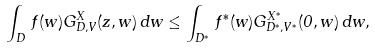<formula> <loc_0><loc_0><loc_500><loc_500>\int _ { D } \, f ( w ) G _ { D , V } ^ { X } ( z , w ) \, d w \leq \int _ { D ^ { * } } \, f ^ { * } ( w ) G _ { D ^ { * } , V ^ { * } } ^ { X ^ { * } } ( 0 , w ) \, d w ,</formula> 